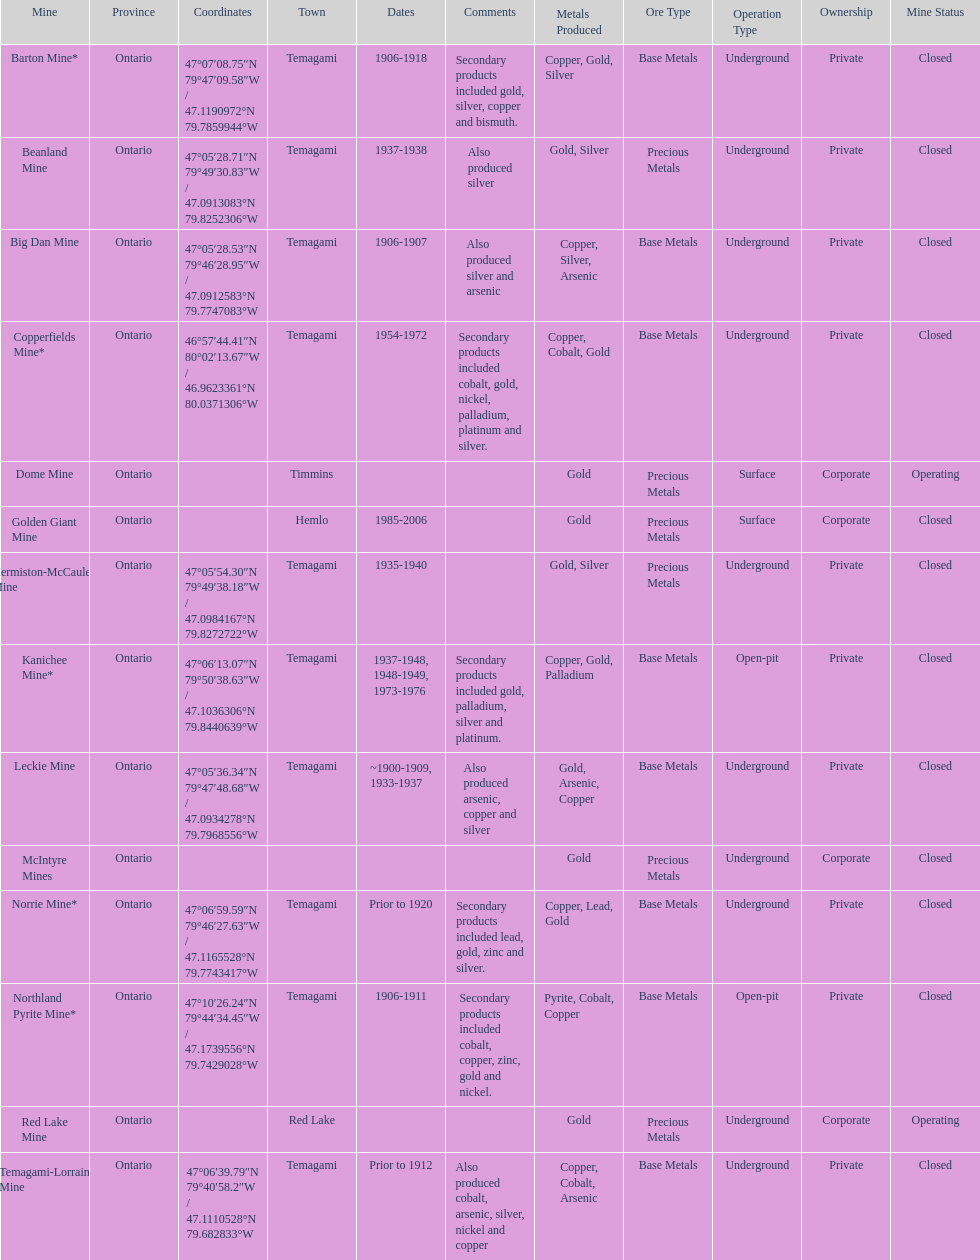Help me parse the entirety of this table. {'header': ['Mine', 'Province', 'Coordinates', 'Town', 'Dates', 'Comments', 'Metals Produced', 'Ore Type', 'Operation Type', 'Ownership', 'Mine Status'], 'rows': [['Barton Mine*', 'Ontario', '47°07′08.75″N 79°47′09.58″W\ufeff / \ufeff47.1190972°N 79.7859944°W', 'Temagami', '1906-1918', 'Secondary products included gold, silver, copper and bismuth.', 'Copper, Gold, Silver', 'Base Metals', 'Underground', 'Private', 'Closed'], ['Beanland Mine', 'Ontario', '47°05′28.71″N 79°49′30.83″W\ufeff / \ufeff47.0913083°N 79.8252306°W', 'Temagami', '1937-1938', 'Also produced silver', 'Gold, Silver', 'Precious Metals', 'Underground', 'Private', 'Closed'], ['Big Dan Mine', 'Ontario', '47°05′28.53″N 79°46′28.95″W\ufeff / \ufeff47.0912583°N 79.7747083°W', 'Temagami', '1906-1907', 'Also produced silver and arsenic', 'Copper, Silver, Arsenic', 'Base Metals', 'Underground', 'Private', 'Closed'], ['Copperfields Mine*', 'Ontario', '46°57′44.41″N 80°02′13.67″W\ufeff / \ufeff46.9623361°N 80.0371306°W', 'Temagami', '1954-1972', 'Secondary products included cobalt, gold, nickel, palladium, platinum and silver.', 'Copper, Cobalt, Gold', 'Base Metals', 'Underground', 'Private', 'Closed'], ['Dome Mine', 'Ontario', '', 'Timmins', '', '', 'Gold', 'Precious Metals', 'Surface', 'Corporate', 'Operating'], ['Golden Giant Mine', 'Ontario', '', 'Hemlo', '1985-2006', '', 'Gold', 'Precious Metals', 'Surface', 'Corporate', 'Closed'], ['Hermiston-McCauley Mine', 'Ontario', '47°05′54.30″N 79°49′38.18″W\ufeff / \ufeff47.0984167°N 79.8272722°W', 'Temagami', '1935-1940', '', 'Gold, Silver', 'Precious Metals', 'Underground', 'Private', 'Closed'], ['Kanichee Mine*', 'Ontario', '47°06′13.07″N 79°50′38.63″W\ufeff / \ufeff47.1036306°N 79.8440639°W', 'Temagami', '1937-1948, 1948-1949, 1973-1976', 'Secondary products included gold, palladium, silver and platinum.', 'Copper, Gold, Palladium', 'Base Metals', 'Open-pit', 'Private', 'Closed'], ['Leckie Mine', 'Ontario', '47°05′36.34″N 79°47′48.68″W\ufeff / \ufeff47.0934278°N 79.7968556°W', 'Temagami', '~1900-1909, 1933-1937', 'Also produced arsenic, copper and silver', 'Gold, Arsenic, Copper', 'Base Metals', 'Underground', 'Private', 'Closed'], ['McIntyre Mines', 'Ontario', '', '', '', '', 'Gold', 'Precious Metals', 'Underground', 'Corporate', 'Closed'], ['Norrie Mine*', 'Ontario', '47°06′59.59″N 79°46′27.63″W\ufeff / \ufeff47.1165528°N 79.7743417°W', 'Temagami', 'Prior to 1920', 'Secondary products included lead, gold, zinc and silver.', 'Copper, Lead, Gold', 'Base Metals', 'Underground', 'Private', 'Closed'], ['Northland Pyrite Mine*', 'Ontario', '47°10′26.24″N 79°44′34.45″W\ufeff / \ufeff47.1739556°N 79.7429028°W', 'Temagami', '1906-1911', 'Secondary products included cobalt, copper, zinc, gold and nickel.', 'Pyrite, Cobalt, Copper', 'Base Metals', 'Open-pit', 'Private', 'Closed'], ['Red Lake Mine', 'Ontario', '', 'Red Lake', '', '', 'Gold', 'Precious Metals', 'Underground', 'Corporate', 'Operating'], ['Temagami-Lorrain Mine', 'Ontario', '47°06′39.79″N 79°40′58.2″W\ufeff / \ufeff47.1110528°N 79.682833°W', 'Temagami', 'Prior to 1912', 'Also produced cobalt, arsenic, silver, nickel and copper', 'Copper, Cobalt, Arsenic', 'Base Metals', 'Underground', 'Private', 'Closed']]} Tell me the number of mines that also produced arsenic. 3. 